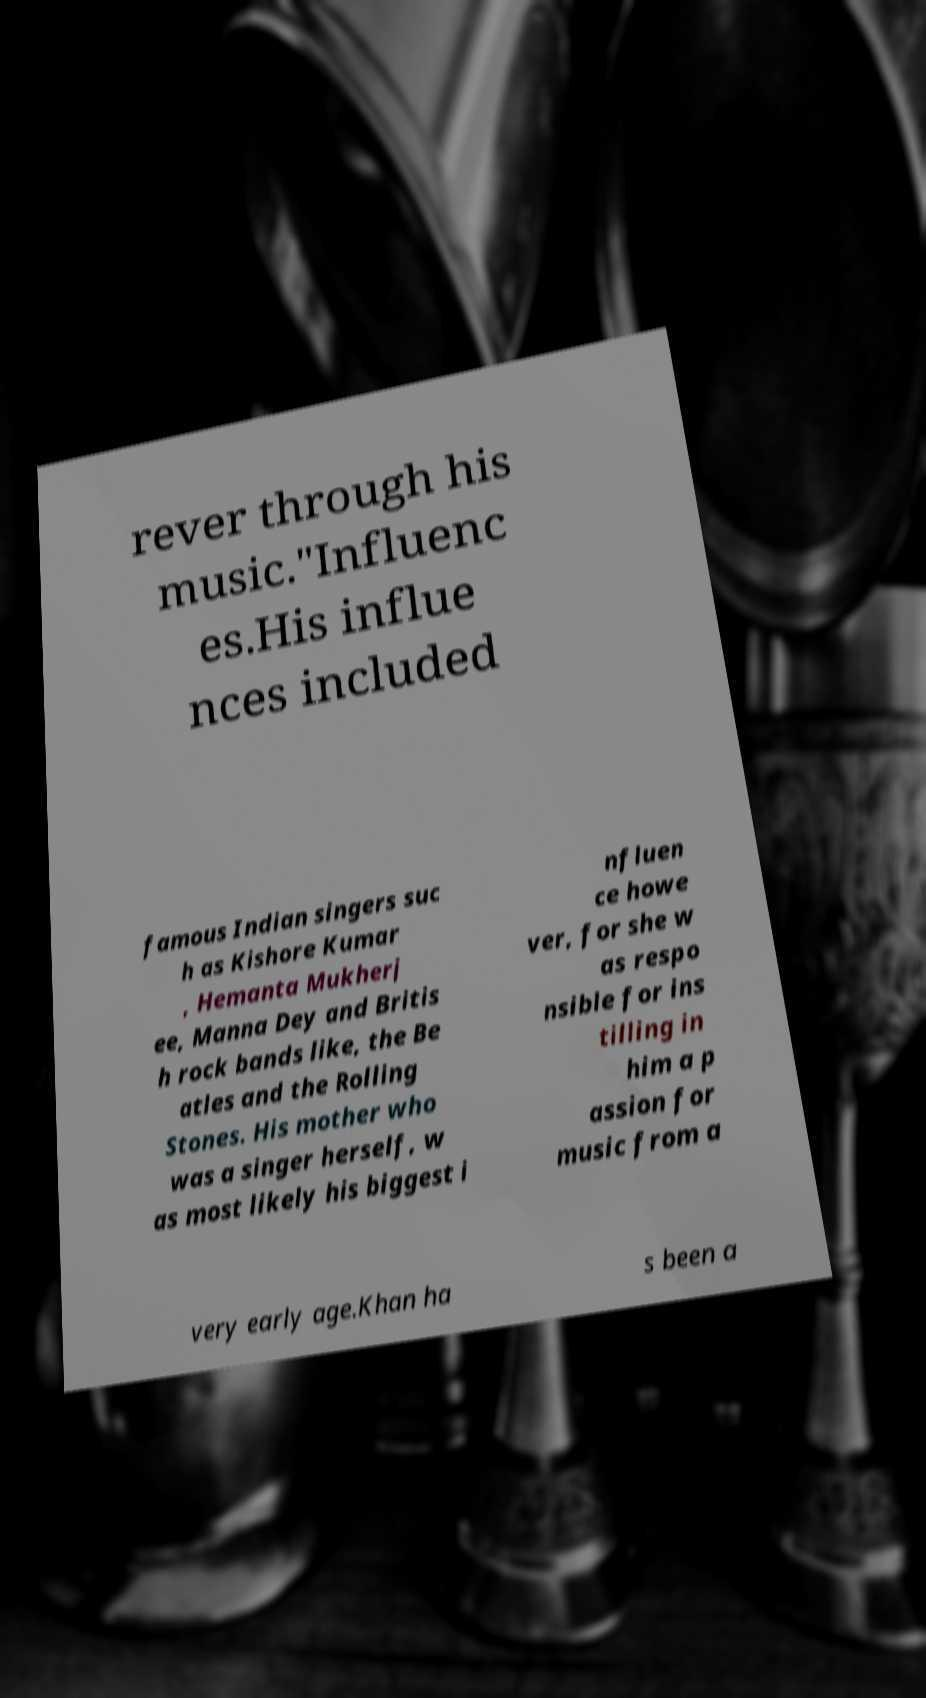What messages or text are displayed in this image? I need them in a readable, typed format. rever through his music."Influenc es.His influe nces included famous Indian singers suc h as Kishore Kumar , Hemanta Mukherj ee, Manna Dey and Britis h rock bands like, the Be atles and the Rolling Stones. His mother who was a singer herself, w as most likely his biggest i nfluen ce howe ver, for she w as respo nsible for ins tilling in him a p assion for music from a very early age.Khan ha s been a 